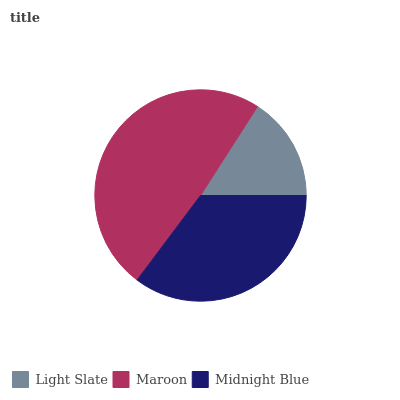Is Light Slate the minimum?
Answer yes or no. Yes. Is Maroon the maximum?
Answer yes or no. Yes. Is Midnight Blue the minimum?
Answer yes or no. No. Is Midnight Blue the maximum?
Answer yes or no. No. Is Maroon greater than Midnight Blue?
Answer yes or no. Yes. Is Midnight Blue less than Maroon?
Answer yes or no. Yes. Is Midnight Blue greater than Maroon?
Answer yes or no. No. Is Maroon less than Midnight Blue?
Answer yes or no. No. Is Midnight Blue the high median?
Answer yes or no. Yes. Is Midnight Blue the low median?
Answer yes or no. Yes. Is Maroon the high median?
Answer yes or no. No. Is Light Slate the low median?
Answer yes or no. No. 